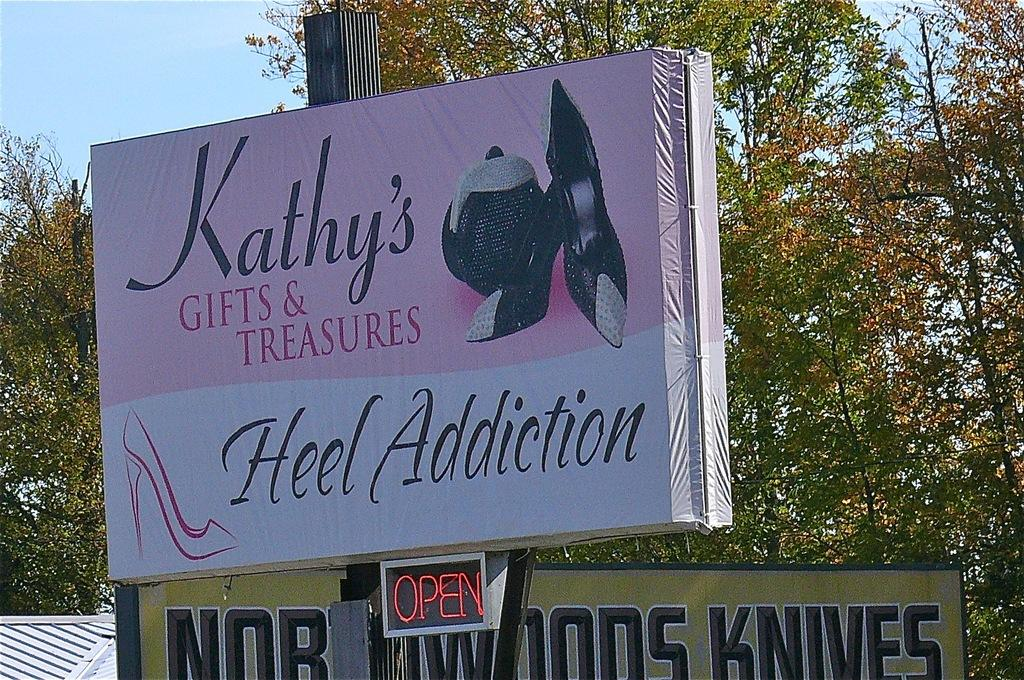<image>
Offer a succinct explanation of the picture presented. A billboard reads "Kathy's Gifts & Treasures Heel Addiction." 